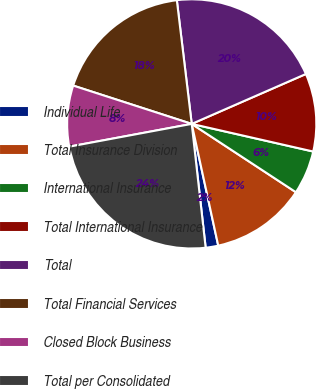Convert chart. <chart><loc_0><loc_0><loc_500><loc_500><pie_chart><fcel>Individual Life<fcel>Total Insurance Division<fcel>International Insurance<fcel>Total International Insurance<fcel>Total<fcel>Total Financial Services<fcel>Closed Block Business<fcel>Total per Consolidated<nl><fcel>1.63%<fcel>12.35%<fcel>5.68%<fcel>10.12%<fcel>20.35%<fcel>18.12%<fcel>7.9%<fcel>23.86%<nl></chart> 